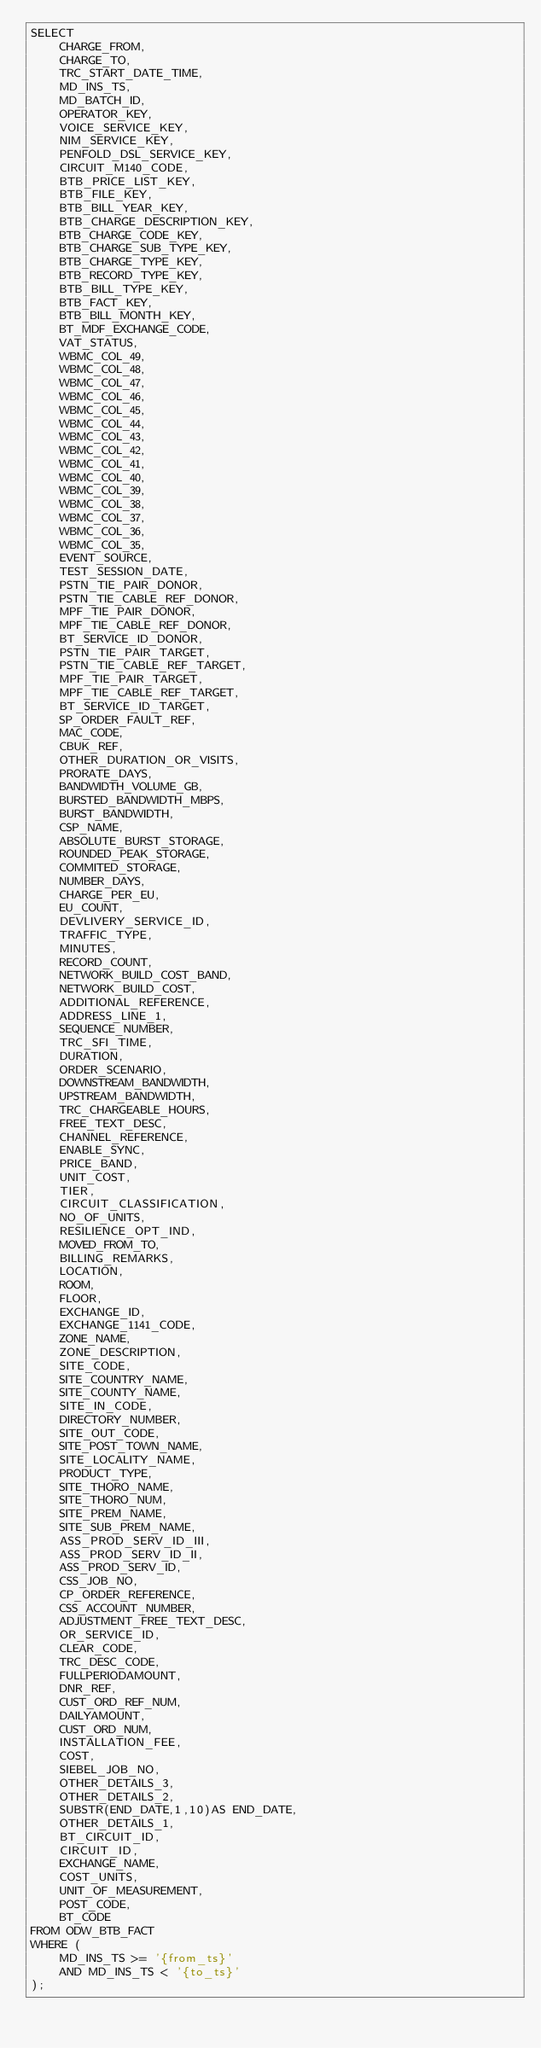<code> <loc_0><loc_0><loc_500><loc_500><_SQL_>SELECT 
    CHARGE_FROM,
    CHARGE_TO,
    TRC_START_DATE_TIME,
    MD_INS_TS,
    MD_BATCH_ID,
    OPERATOR_KEY,
    VOICE_SERVICE_KEY,
    NIM_SERVICE_KEY,
    PENFOLD_DSL_SERVICE_KEY,
    CIRCUIT_M140_CODE,
    BTB_PRICE_LIST_KEY,
    BTB_FILE_KEY,
    BTB_BILL_YEAR_KEY,
    BTB_CHARGE_DESCRIPTION_KEY,
    BTB_CHARGE_CODE_KEY,
    BTB_CHARGE_SUB_TYPE_KEY,
    BTB_CHARGE_TYPE_KEY,
    BTB_RECORD_TYPE_KEY,
    BTB_BILL_TYPE_KEY,
    BTB_FACT_KEY,
    BTB_BILL_MONTH_KEY,
    BT_MDF_EXCHANGE_CODE,
    VAT_STATUS,
    WBMC_COL_49,
    WBMC_COL_48,
    WBMC_COL_47,
    WBMC_COL_46,
    WBMC_COL_45,
    WBMC_COL_44,
    WBMC_COL_43,
    WBMC_COL_42,
    WBMC_COL_41,
    WBMC_COL_40,
    WBMC_COL_39,
    WBMC_COL_38,
    WBMC_COL_37,
    WBMC_COL_36,
    WBMC_COL_35,
    EVENT_SOURCE,
    TEST_SESSION_DATE,
    PSTN_TIE_PAIR_DONOR,
    PSTN_TIE_CABLE_REF_DONOR,
    MPF_TIE_PAIR_DONOR,
    MPF_TIE_CABLE_REF_DONOR,
    BT_SERVICE_ID_DONOR,
    PSTN_TIE_PAIR_TARGET,
    PSTN_TIE_CABLE_REF_TARGET,
    MPF_TIE_PAIR_TARGET,
    MPF_TIE_CABLE_REF_TARGET,
    BT_SERVICE_ID_TARGET,
    SP_ORDER_FAULT_REF,
    MAC_CODE,
    CBUK_REF,
    OTHER_DURATION_OR_VISITS,
    PRORATE_DAYS,
    BANDWIDTH_VOLUME_GB,
    BURSTED_BANDWIDTH_MBPS,
    BURST_BANDWIDTH,
    CSP_NAME,
    ABSOLUTE_BURST_STORAGE,
    ROUNDED_PEAK_STORAGE,
    COMMITED_STORAGE,
    NUMBER_DAYS,
    CHARGE_PER_EU,
    EU_COUNT,
    DEVLIVERY_SERVICE_ID,
    TRAFFIC_TYPE,
    MINUTES,
    RECORD_COUNT,
    NETWORK_BUILD_COST_BAND,
    NETWORK_BUILD_COST,
    ADDITIONAL_REFERENCE,
    ADDRESS_LINE_1,
    SEQUENCE_NUMBER,
    TRC_SFI_TIME,
    DURATION,
    ORDER_SCENARIO,
    DOWNSTREAM_BANDWIDTH,
    UPSTREAM_BANDWIDTH,
    TRC_CHARGEABLE_HOURS,
    FREE_TEXT_DESC,
    CHANNEL_REFERENCE,
    ENABLE_SYNC,
    PRICE_BAND,
    UNIT_COST,
    TIER,
    CIRCUIT_CLASSIFICATION,
    NO_OF_UNITS,
    RESILIENCE_OPT_IND,
    MOVED_FROM_TO,
    BILLING_REMARKS,
    LOCATION,
    ROOM,
    FLOOR,
    EXCHANGE_ID,
    EXCHANGE_1141_CODE,
    ZONE_NAME,
    ZONE_DESCRIPTION,
    SITE_CODE,
    SITE_COUNTRY_NAME,
    SITE_COUNTY_NAME,
    SITE_IN_CODE,
    DIRECTORY_NUMBER,
    SITE_OUT_CODE,
    SITE_POST_TOWN_NAME,
    SITE_LOCALITY_NAME,
    PRODUCT_TYPE,
    SITE_THORO_NAME,
    SITE_THORO_NUM,
    SITE_PREM_NAME,
    SITE_SUB_PREM_NAME,
    ASS_PROD_SERV_ID_III,
    ASS_PROD_SERV_ID_II,
    ASS_PROD_SERV_ID,
    CSS_JOB_NO,
    CP_ORDER_REFERENCE,
    CSS_ACCOUNT_NUMBER,
    ADJUSTMENT_FREE_TEXT_DESC,
    OR_SERVICE_ID,
    CLEAR_CODE,
    TRC_DESC_CODE,
    FULLPERIODAMOUNT,
    DNR_REF,
    CUST_ORD_REF_NUM,
    DAILYAMOUNT,
    CUST_ORD_NUM,
    INSTALLATION_FEE,
    COST,
    SIEBEL_JOB_NO,
    OTHER_DETAILS_3,
    OTHER_DETAILS_2,
    SUBSTR(END_DATE,1,10)AS END_DATE,
    OTHER_DETAILS_1,
    BT_CIRCUIT_ID,
    CIRCUIT_ID,
    EXCHANGE_NAME,
    COST_UNITS,
    UNIT_OF_MEASUREMENT,
    POST_CODE,
    BT_CODE
FROM ODW_BTB_FACT
WHERE (
    MD_INS_TS >= '{from_ts}'
    AND MD_INS_TS < '{to_ts}'
);
</code> 